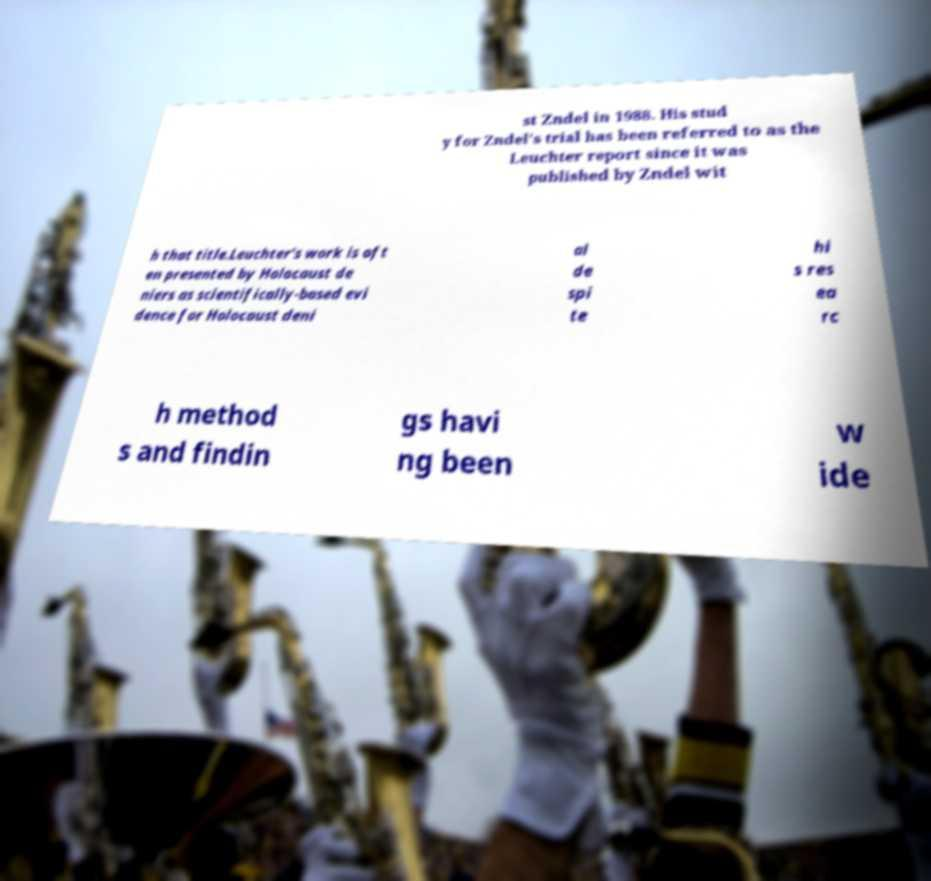There's text embedded in this image that I need extracted. Can you transcribe it verbatim? st Zndel in 1988. His stud y for Zndel's trial has been referred to as the Leuchter report since it was published by Zndel wit h that title.Leuchter's work is oft en presented by Holocaust de niers as scientifically-based evi dence for Holocaust deni al de spi te hi s res ea rc h method s and findin gs havi ng been w ide 